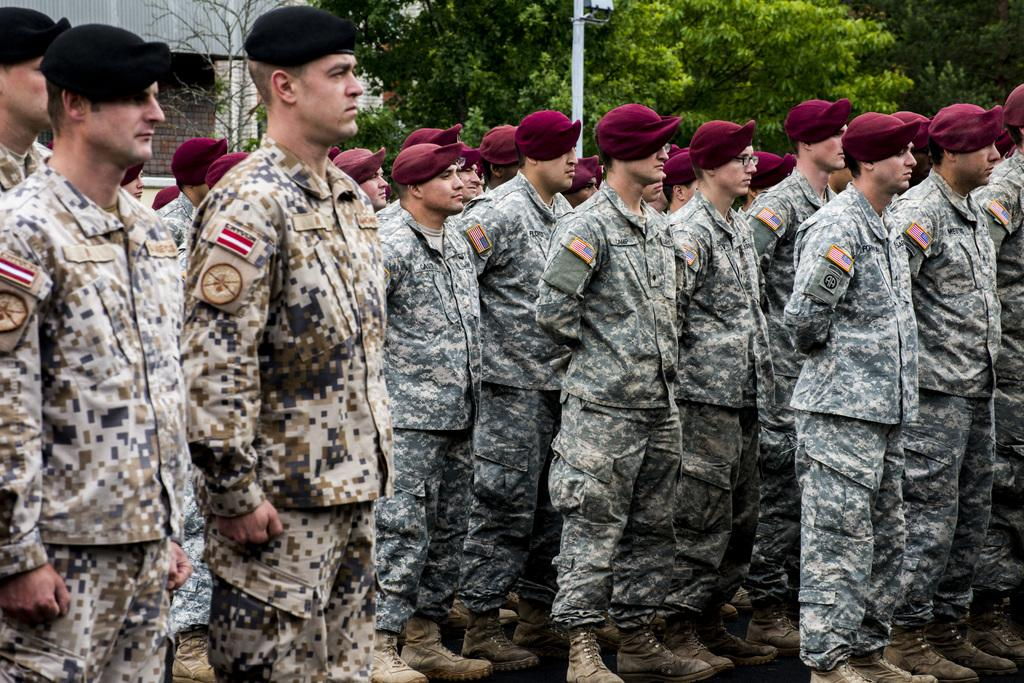What is happening in the image? There is a group of people standing in the image. What can be seen in the background of the image? There is a pole, trees, and a wall in the background of the image. What type of book is the turkey reading in the image? There is no turkey or book present in the image. 